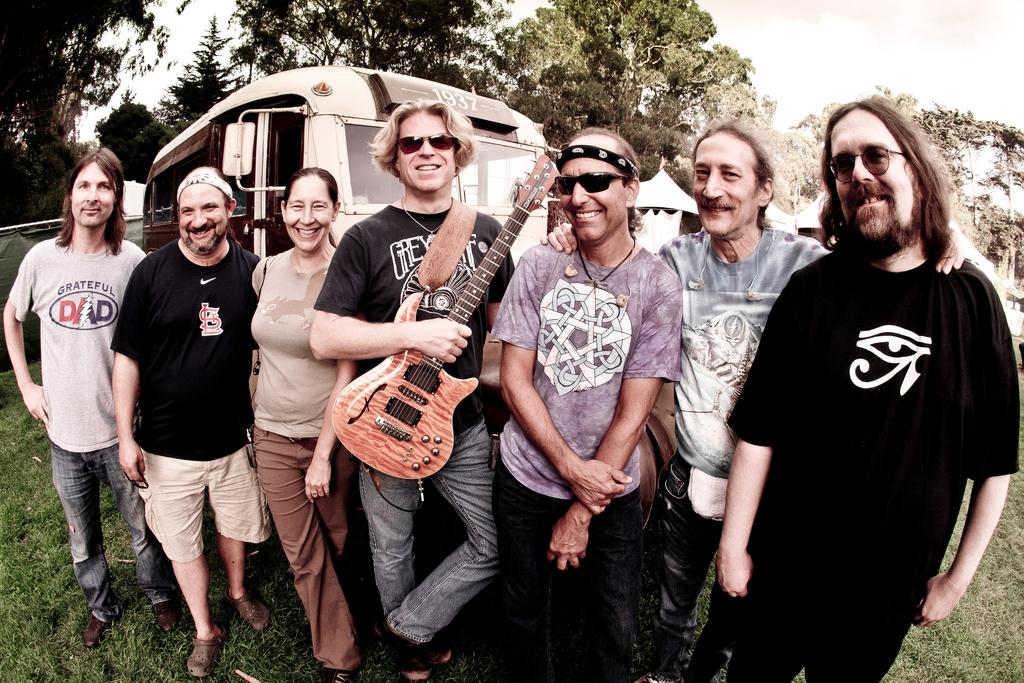How many people are in the image? There is a group of people in the image. What are the people in the image doing? The people are posing for a camera. What type of rock is the woman holding in the image? There is no woman or rock present in the image; it only features a group of people posing for a camera. 